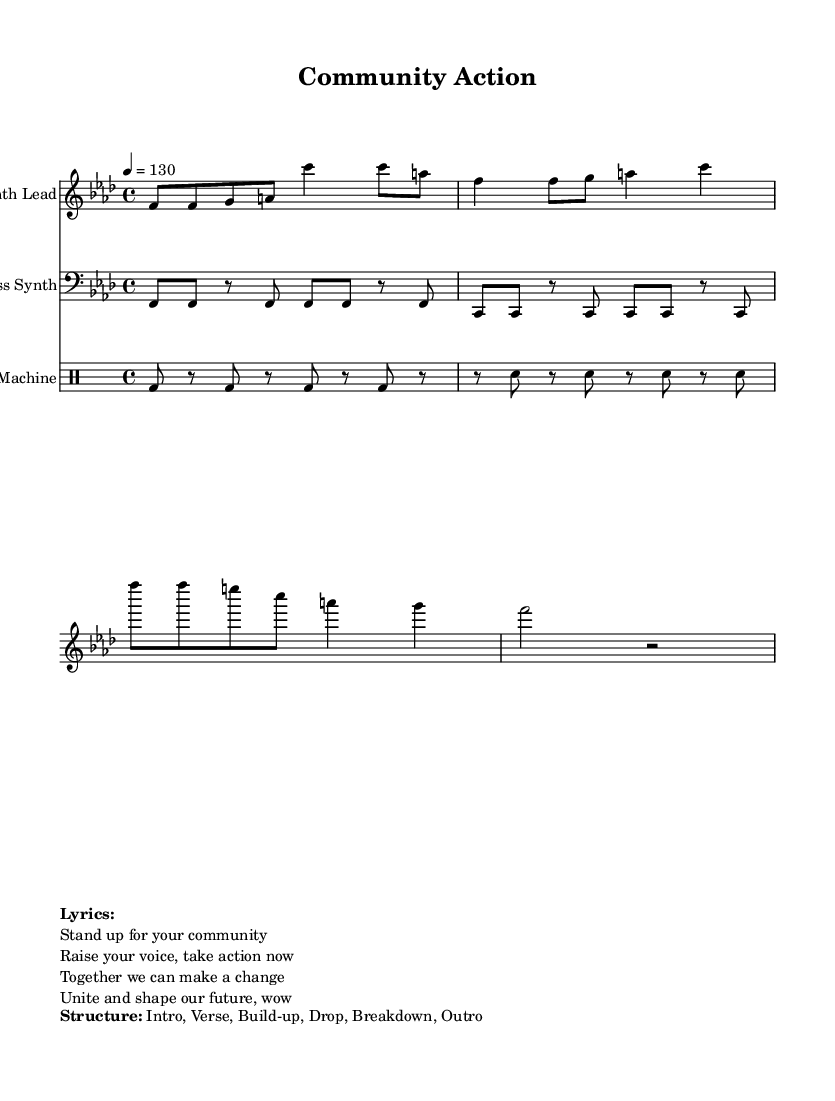What is the key signature of this music? The key signature is indicated at the beginning of the score. In this case, it shows a flat on the F line, indicating F minor.
Answer: F minor What is the time signature of this music? The time signature is located right after the key signature. It is 4/4, which means there are four beats in each measure.
Answer: 4/4 What is the tempo of the piece? The tempo marking indicates the speed of the music. It shows "4 = 130," meaning there are 130 beats per minute.
Answer: 130 How many main sections are described in the structure? The structure outlines six sections: Intro, Verse, Build-up, Drop, Breakdown, and Outro. Counting each section gives a total of six.
Answer: 6 What instruments are used in this piece? The instruments are listed in the score under each staff: Synth Lead, Bass Synth, and Drum Machine. Therefore, there are three instruments used.
Answer: Three instruments What lyrics are included in this music? The lyrics are presented in the markup section. They convey messages about community engagement and action. The first line is "Stand up for your community."
Answer: "Stand up for your community." What type of music does this sheet represent? The overall theme and style of the music indicated by the energetic beats and structure are characteristic of Dance music.
Answer: Dance 